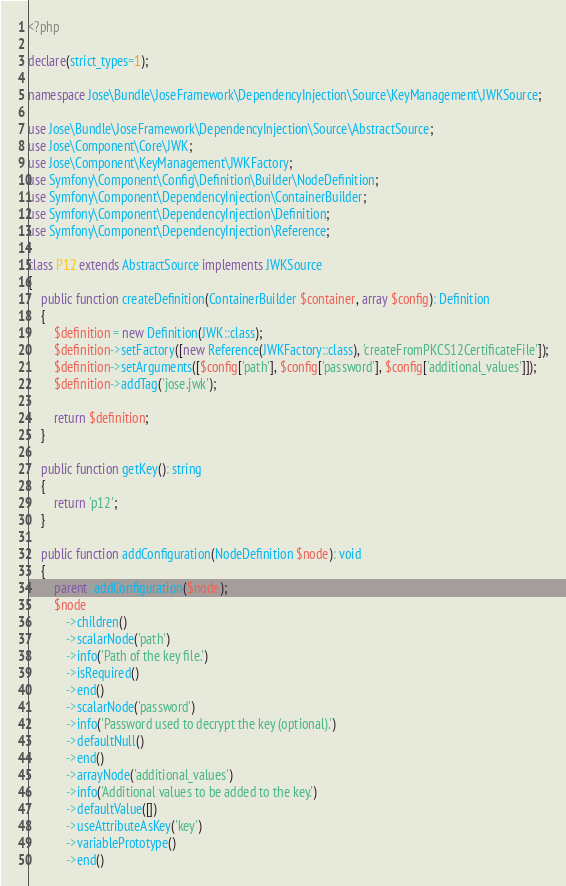Convert code to text. <code><loc_0><loc_0><loc_500><loc_500><_PHP_><?php

declare(strict_types=1);

namespace Jose\Bundle\JoseFramework\DependencyInjection\Source\KeyManagement\JWKSource;

use Jose\Bundle\JoseFramework\DependencyInjection\Source\AbstractSource;
use Jose\Component\Core\JWK;
use Jose\Component\KeyManagement\JWKFactory;
use Symfony\Component\Config\Definition\Builder\NodeDefinition;
use Symfony\Component\DependencyInjection\ContainerBuilder;
use Symfony\Component\DependencyInjection\Definition;
use Symfony\Component\DependencyInjection\Reference;

class P12 extends AbstractSource implements JWKSource
{
    public function createDefinition(ContainerBuilder $container, array $config): Definition
    {
        $definition = new Definition(JWK::class);
        $definition->setFactory([new Reference(JWKFactory::class), 'createFromPKCS12CertificateFile']);
        $definition->setArguments([$config['path'], $config['password'], $config['additional_values']]);
        $definition->addTag('jose.jwk');

        return $definition;
    }

    public function getKey(): string
    {
        return 'p12';
    }

    public function addConfiguration(NodeDefinition $node): void
    {
        parent::addConfiguration($node);
        $node
            ->children()
            ->scalarNode('path')
            ->info('Path of the key file.')
            ->isRequired()
            ->end()
            ->scalarNode('password')
            ->info('Password used to decrypt the key (optional).')
            ->defaultNull()
            ->end()
            ->arrayNode('additional_values')
            ->info('Additional values to be added to the key.')
            ->defaultValue([])
            ->useAttributeAsKey('key')
            ->variablePrototype()
            ->end()</code> 